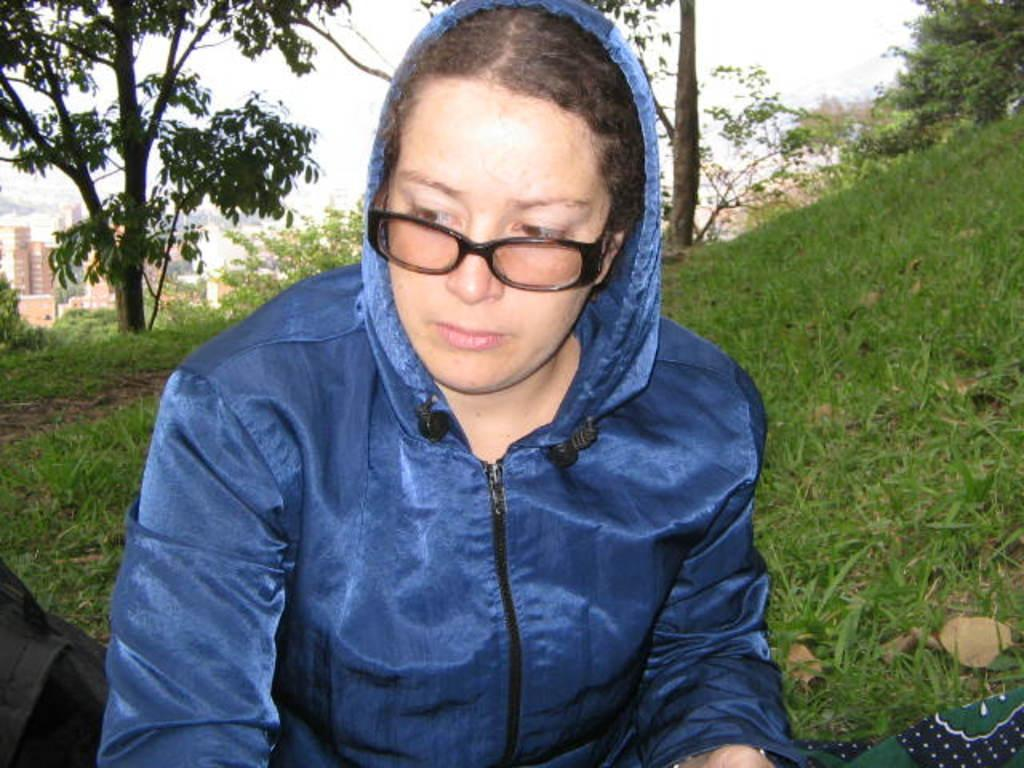Who is present in the image? There is a woman in the image. What is the woman wearing on her face? The woman is wearing spectacles. What type of natural environment is visible in the image? There is grass visible in the image. What can be seen in the distance in the image? There are trees, buildings, and the sky visible in the background of the image. How does the woman test the sink in the image? There is no sink present in the image, so it is not possible to answer that question. 